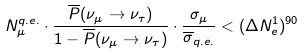<formula> <loc_0><loc_0><loc_500><loc_500>N _ { \mu } ^ { q . e . } \cdot \frac { \overline { P } ( \nu _ { \mu } \rightarrow \nu _ { \tau } ) } { 1 - \overline { P } ( \nu _ { \mu } \rightarrow \nu _ { \tau } ) } \cdot \frac { \sigma _ { \mu } } { \overline { \sigma } _ { q . e . } } < ( \Delta N _ { e } ^ { 1 } ) ^ { 9 0 }</formula> 